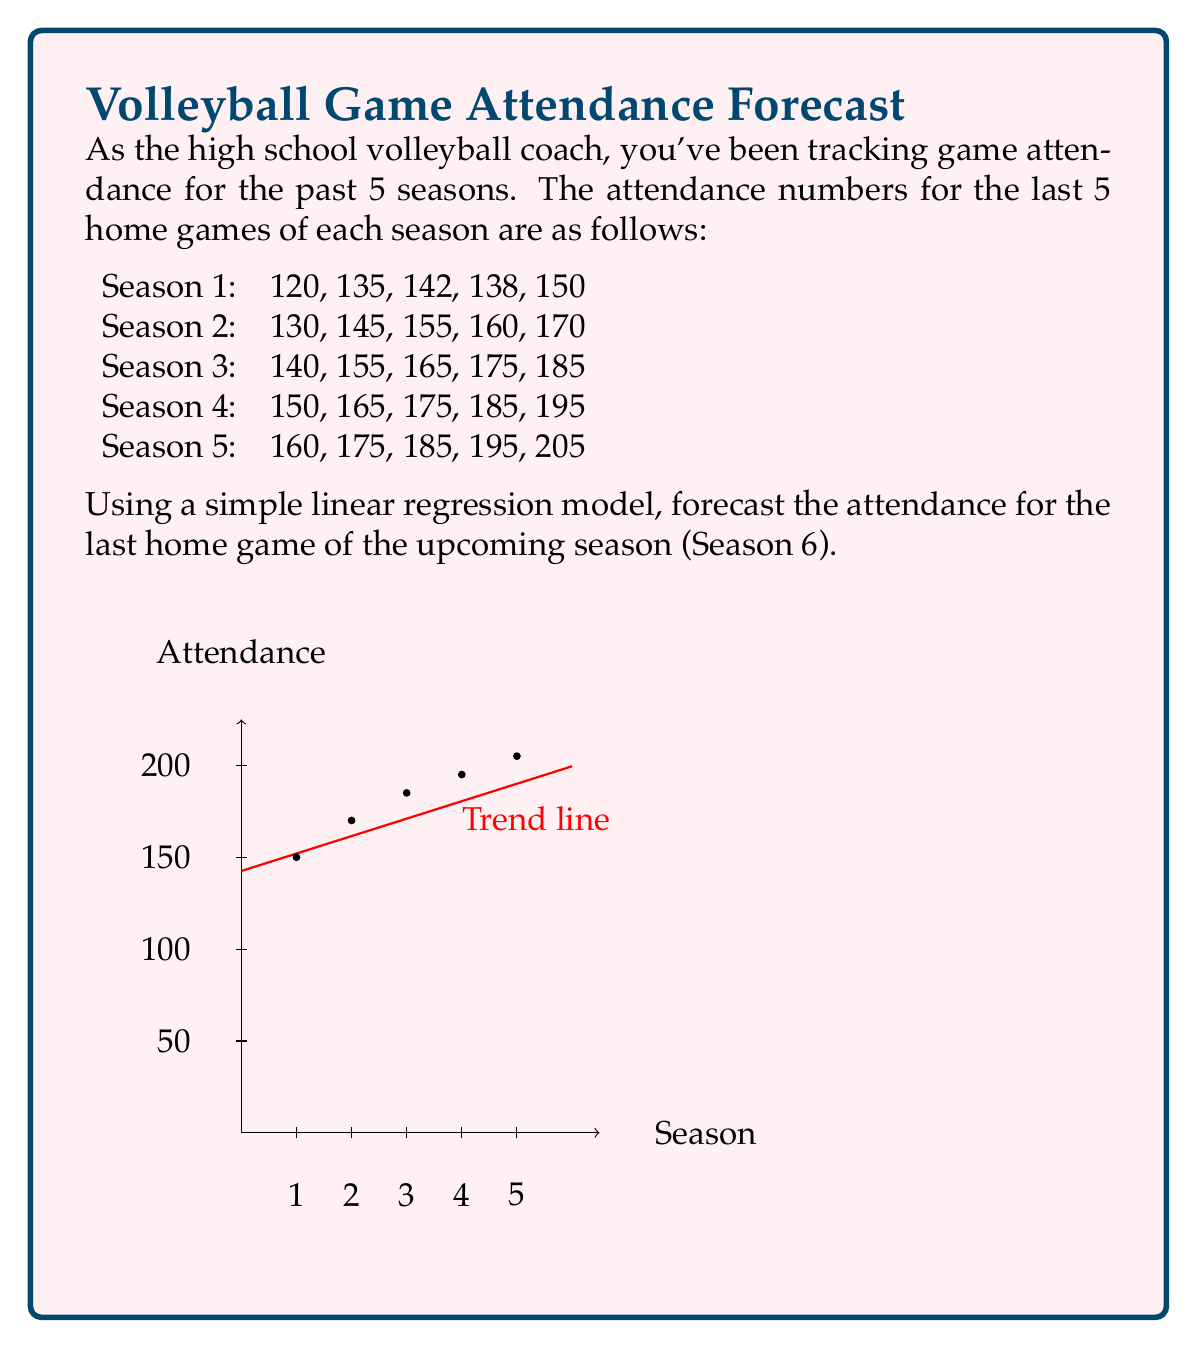Can you answer this question? To forecast the attendance for Season 6, we'll use a simple linear regression model. The steps are as follows:

1) First, we need to identify our data points. We'll use the attendance of the last game of each season:
   Season 1: 150
   Season 2: 170
   Season 3: 185
   Season 4: 195
   Season 5: 205

2) Let's define our variables:
   $x$: Season number (1, 2, 3, 4, 5)
   $y$: Attendance

3) We need to calculate the following:
   $\bar{x}$ (mean of x), $\bar{y}$ (mean of y), $\sum x^2$, $\sum xy$

   $\bar{x} = \frac{1+2+3+4+5}{5} = 3$
   $\bar{y} = \frac{150+170+185+195+205}{5} = 181$
   $\sum x^2 = 1^2 + 2^2 + 3^2 + 4^2 + 5^2 = 55$
   $\sum xy = 1(150) + 2(170) + 3(185) + 4(195) + 5(205) = 2775$

4) Now we can calculate the slope (m) and y-intercept (b) of our regression line:

   $m = \frac{n\sum xy - \sum x \sum y}{n\sum x^2 - (\sum x)^2}$
   $= \frac{5(2775) - (15)(905)}{5(55) - 15^2} = \frac{13875 - 13575}{275 - 225} = \frac{300}{50} = 15.5$

   $b = \bar{y} - m\bar{x} = 181 - 15.5(3) = 134.5$

5) Our regression equation is: $y = 15.5x + 134.5$

6) To forecast Season 6, we substitute $x = 6$ into our equation:

   $y = 15.5(6) + 134.5 = 93 + 134.5 = 227.5$

Therefore, the forecasted attendance for the last home game of Season 6 is approximately 228 people (rounded to the nearest whole number).
Answer: 228 people 